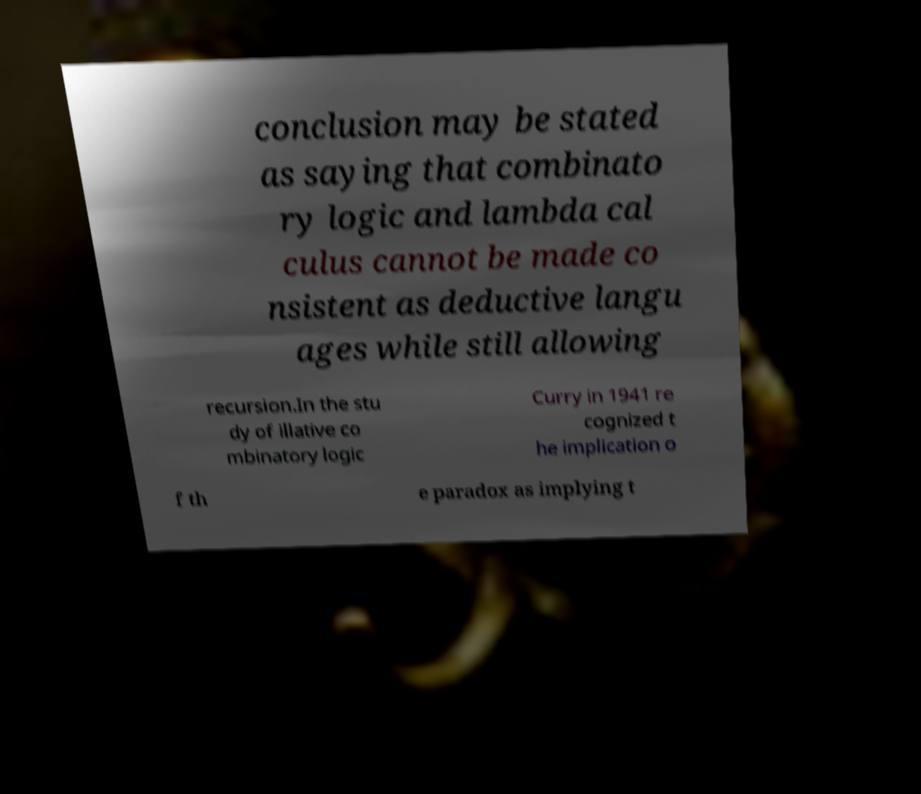For documentation purposes, I need the text within this image transcribed. Could you provide that? conclusion may be stated as saying that combinato ry logic and lambda cal culus cannot be made co nsistent as deductive langu ages while still allowing recursion.In the stu dy of illative co mbinatory logic Curry in 1941 re cognized t he implication o f th e paradox as implying t 